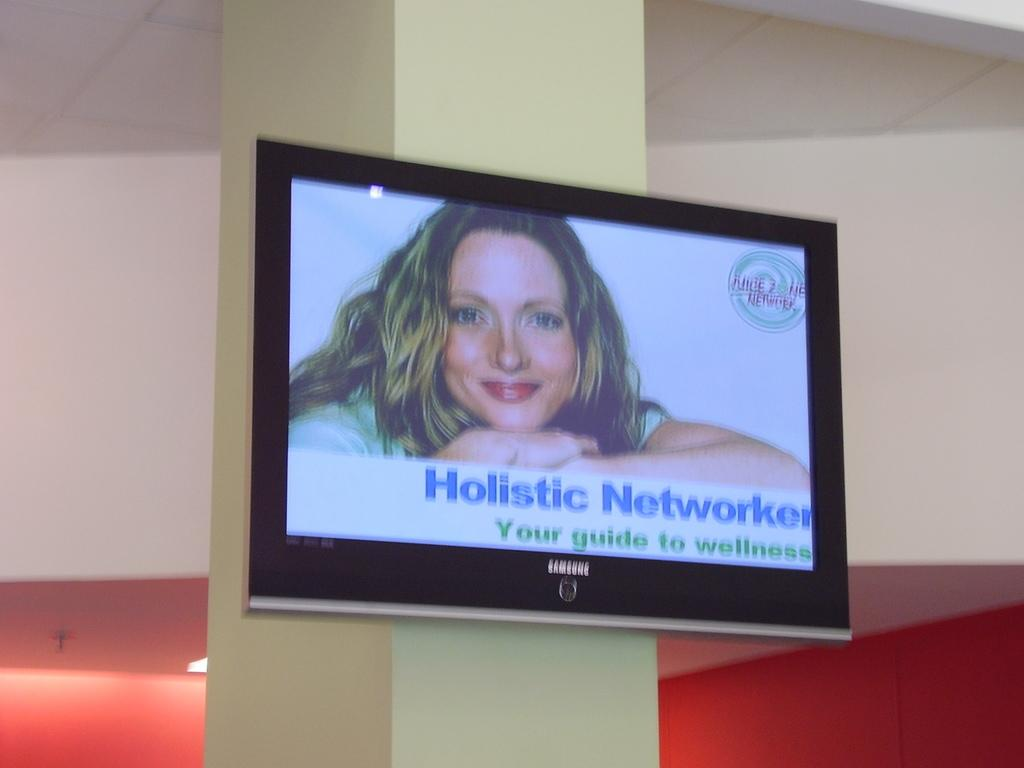Provide a one-sentence caption for the provided image. A Samsung TV screen displays a woman known as the Holistic Networker. 